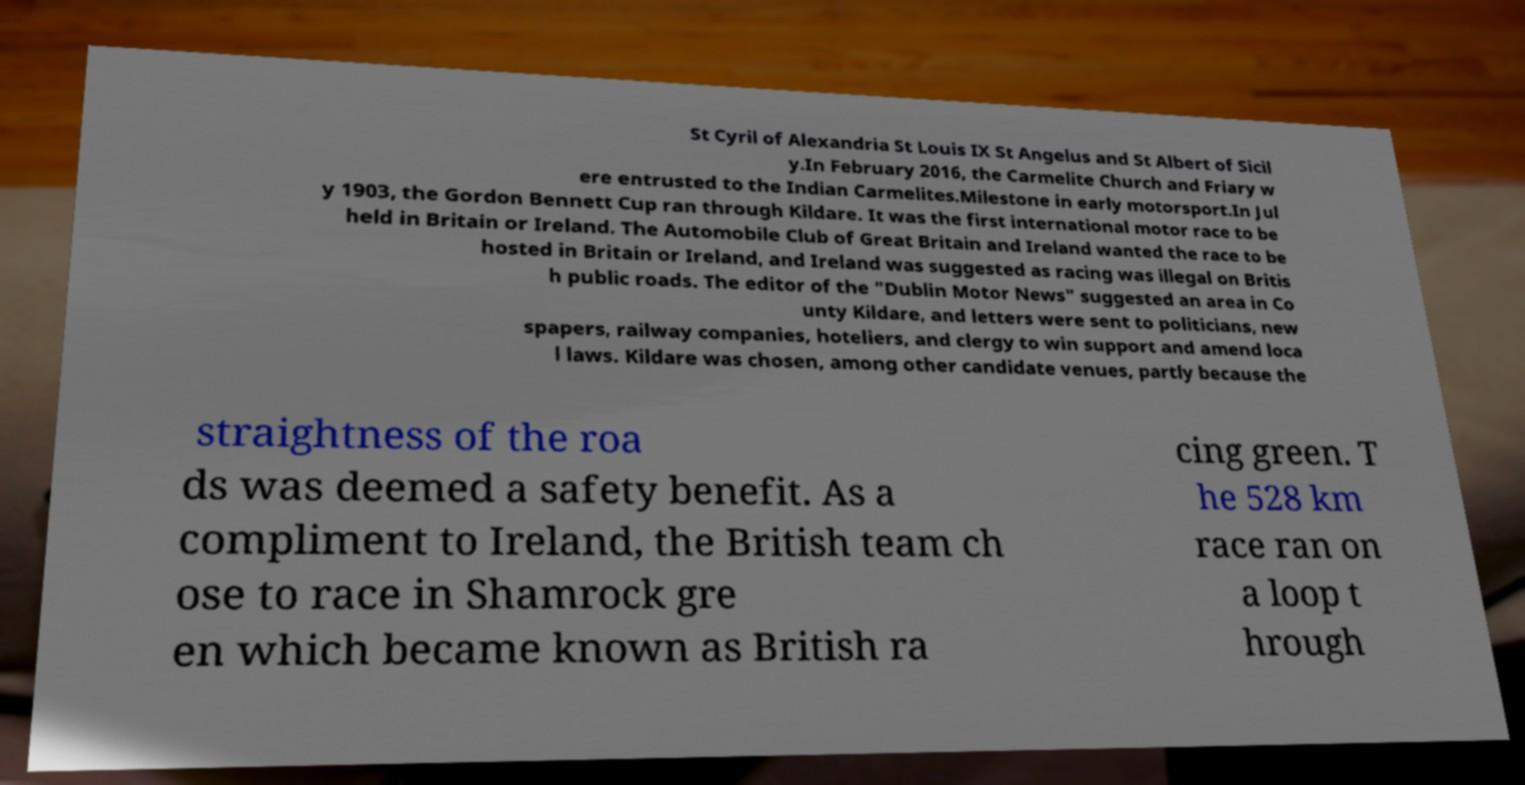There's text embedded in this image that I need extracted. Can you transcribe it verbatim? St Cyril of Alexandria St Louis IX St Angelus and St Albert of Sicil y.In February 2016, the Carmelite Church and Friary w ere entrusted to the Indian Carmelites.Milestone in early motorsport.In Jul y 1903, the Gordon Bennett Cup ran through Kildare. It was the first international motor race to be held in Britain or Ireland. The Automobile Club of Great Britain and Ireland wanted the race to be hosted in Britain or Ireland, and Ireland was suggested as racing was illegal on Britis h public roads. The editor of the "Dublin Motor News" suggested an area in Co unty Kildare, and letters were sent to politicians, new spapers, railway companies, hoteliers, and clergy to win support and amend loca l laws. Kildare was chosen, among other candidate venues, partly because the straightness of the roa ds was deemed a safety benefit. As a compliment to Ireland, the British team ch ose to race in Shamrock gre en which became known as British ra cing green. T he 528 km race ran on a loop t hrough 